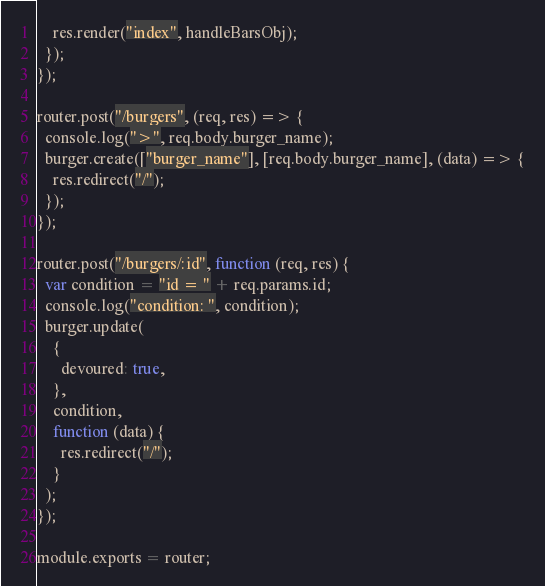Convert code to text. <code><loc_0><loc_0><loc_500><loc_500><_JavaScript_>    res.render("index", handleBarsObj);
  });
});

router.post("/burgers", (req, res) => {
  console.log(">", req.body.burger_name);
  burger.create(["burger_name"], [req.body.burger_name], (data) => {
    res.redirect("/");
  });
});

router.post("/burgers/:id", function (req, res) {
  var condition = "id = " + req.params.id;
  console.log("condition: ", condition);
  burger.update(
    {
      devoured: true,
    },
    condition,
    function (data) {
      res.redirect("/");
    }
  );
});

module.exports = router;</code> 